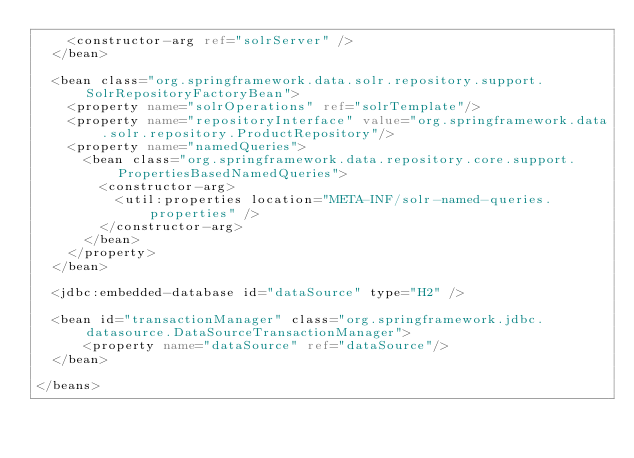Convert code to text. <code><loc_0><loc_0><loc_500><loc_500><_XML_>		<constructor-arg ref="solrServer" />
	</bean>
	
	<bean class="org.springframework.data.solr.repository.support.SolrRepositoryFactoryBean">
		<property name="solrOperations" ref="solrTemplate"/>
		<property name="repositoryInterface" value="org.springframework.data.solr.repository.ProductRepository"/>
		<property name="namedQueries">
			<bean class="org.springframework.data.repository.core.support.PropertiesBasedNamedQueries">
				<constructor-arg>
					<util:properties location="META-INF/solr-named-queries.properties" />
				</constructor-arg>
			</bean>
		</property>
	</bean>
	
	<jdbc:embedded-database id="dataSource" type="H2" />
	 	
	<bean id="transactionManager" class="org.springframework.jdbc.datasource.DataSourceTransactionManager">
    	<property name="dataSource" ref="dataSource"/>
	</bean>	

</beans></code> 